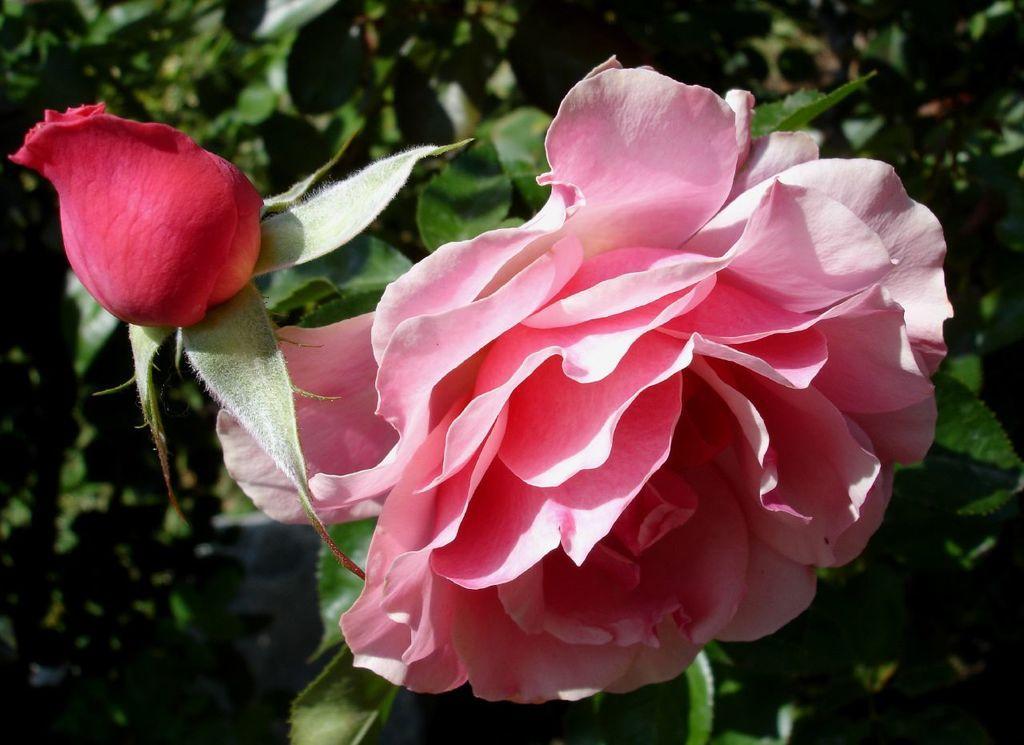In one or two sentences, can you explain what this image depicts? In this picture we can see flowers and plants. 